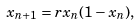<formula> <loc_0><loc_0><loc_500><loc_500>x _ { n + 1 } = r x _ { n } ( 1 - x _ { n } ) ,</formula> 